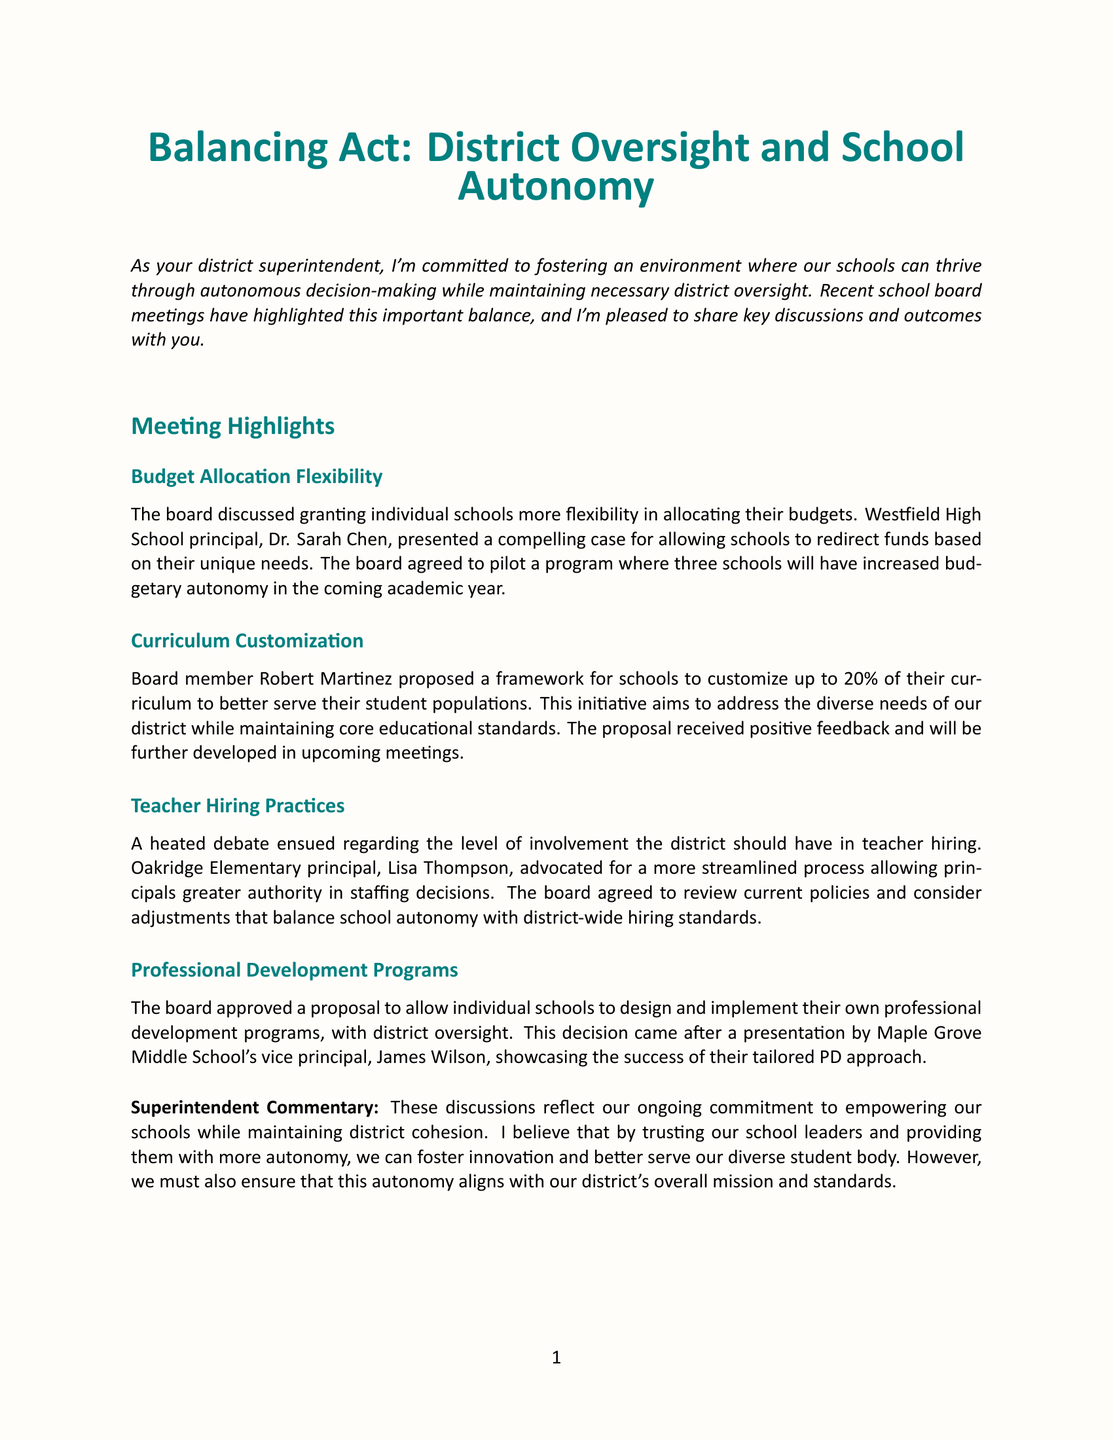What is the title of the newsletter? The title of the newsletter is found at the beginning, indicating the primary focus or theme.
Answer: Balancing Act: District Oversight and School Autonomy Who presented the case for budget allocation flexibility? The document mentions that a specific principal presented a case during the discussion about budget allocation.
Answer: Dr. Sarah Chen What percentage of the curriculum can schools customize according to Robert Martinez's proposal? The proposal made by board member Robert Martinez specifies a particular percentage of curriculum customization.
Answer: 20% What is the main topic of the "Teacher Hiring Practices" discussion? The discussion primarily revolved around the level of district involvement in a certain process related to staffing.
Answer: Teacher hiring What is one upcoming initiative mentioned in the newsletter? The document lists future initiatives aimed at enhancing decision-making within schools.
Answer: School Leadership Summit How many schools will have increased budgetary autonomy in the pilot program? The number of schools participating in the pilot program is stated clearly in the meeting highlights.
Answer: Three What did James Wilson showcase in his presentation? The document highlights a specific aspect of a presentation made by a vice principal, relating to professional development.
Answer: Tailored PD approach What is the goal of the town halls and online surveys? The purpose of these initiatives is outlined in the upcoming initiatives section, pertaining to gathering input from the community.
Answer: Balance between district oversight and school autonomy 